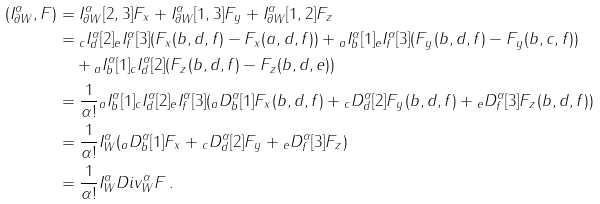<formula> <loc_0><loc_0><loc_500><loc_500>( { I _ { \partial W } ^ { \alpha } } , F ) & = { I ^ { \alpha } _ { \partial W } } [ 2 , 3 ] F _ { x } + { I ^ { \alpha } _ { \partial W } } [ 1 , 3 ] F _ { y } + { I ^ { \alpha } _ { \partial W } } [ 1 , 2 ] F _ { z } \\ & = { _ { c } I _ { d } ^ { \alpha } } [ 2 ] { _ { e } I _ { f } ^ { \alpha } } [ 3 ] ( F _ { x } ( b , d , f ) - F _ { x } ( a , d , f ) ) + { _ { a } I _ { b } ^ { \alpha } } [ 1 ] { _ { e } I _ { f } ^ { \alpha } } [ 3 ] ( F _ { y } ( b , d , f ) - F _ { y } ( b , c , f ) ) \\ & \quad + { _ { a } I _ { b } ^ { \alpha } } [ 1 ] { _ { c } I _ { d } ^ { \alpha } } [ 2 ] ( F _ { z } ( b , d , f ) - F _ { z } ( b , d , e ) ) \\ & = \frac { 1 } { \alpha ! } { _ { a } I _ { b } ^ { \alpha } } [ 1 ] { { _ { c } } I _ { d } ^ { \alpha } } [ 2 ] { { _ { e } } I _ { f } ^ { \alpha } } [ 3 ] ( { _ { a } D _ { b } ^ { \alpha } } [ 1 ] F _ { x } ( b , d , f ) + { _ { c } D _ { d } ^ { \alpha } } [ 2 ] F _ { y } ( b , d , f ) + { _ { e } D _ { f } ^ { \alpha } } [ 3 ] F _ { z } ( b , d , f ) ) \\ & = \frac { 1 } { \alpha ! } { I _ { W } ^ { \alpha } } ( { _ { a } D _ { b } ^ { \alpha } } [ 1 ] F _ { x } + { _ { c } D _ { d } ^ { \alpha } } [ 2 ] F _ { y } + { _ { e } D _ { f } ^ { \alpha } } [ 3 ] F _ { z } ) \\ & = \frac { 1 } { \alpha ! } { I _ { W } ^ { \alpha } } { D i v _ { W } ^ { \alpha } } F \, .</formula> 